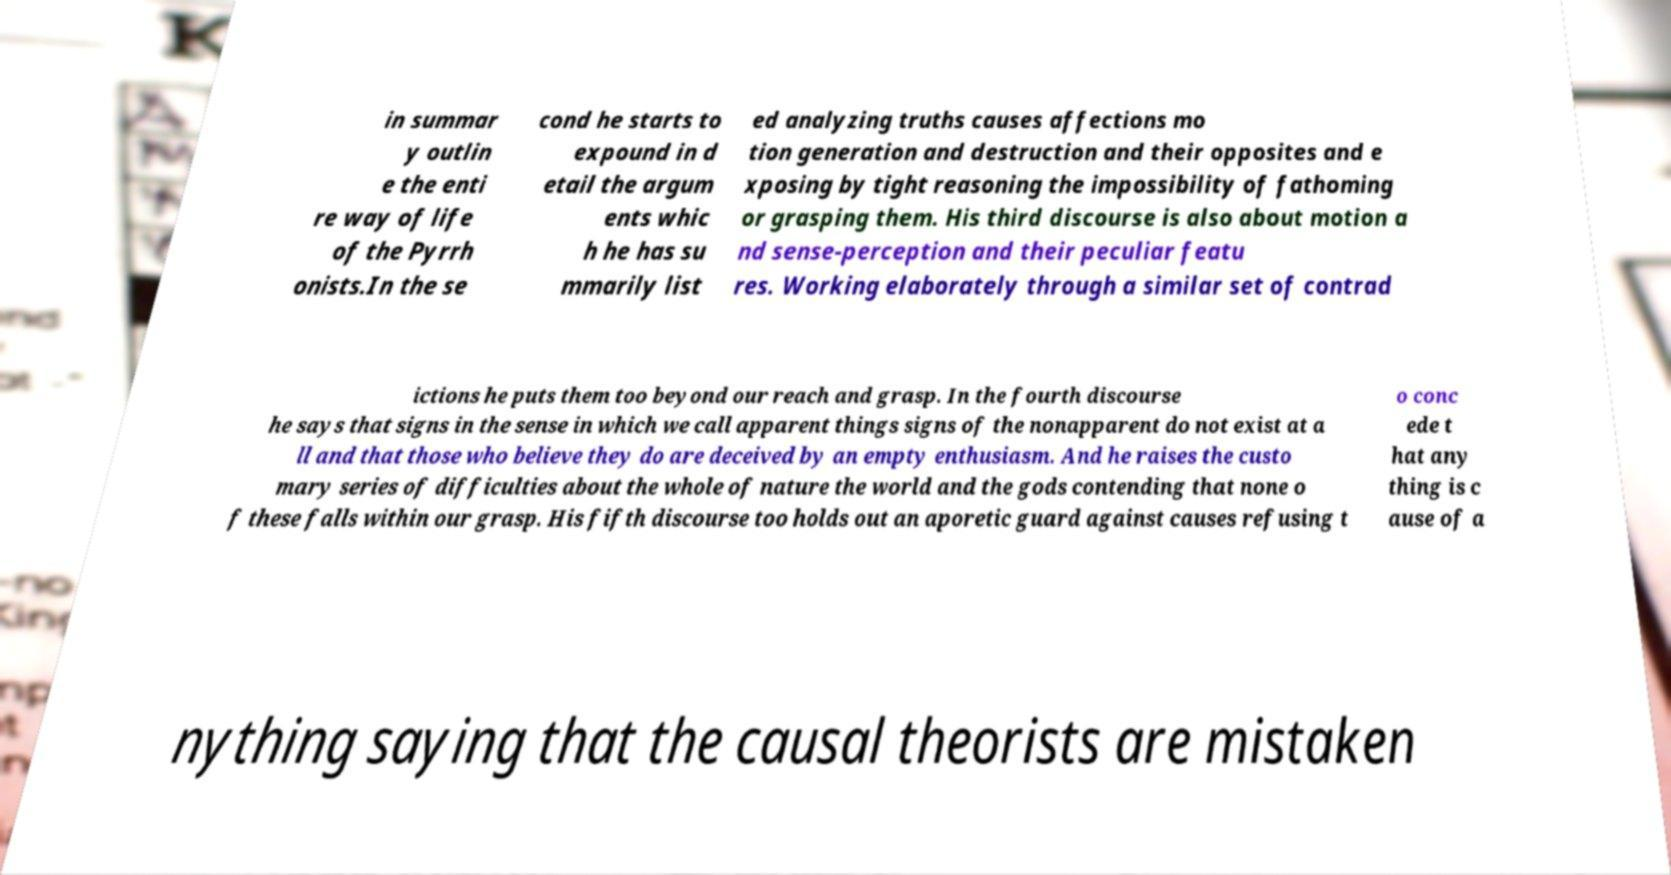Can you accurately transcribe the text from the provided image for me? in summar y outlin e the enti re way of life of the Pyrrh onists.In the se cond he starts to expound in d etail the argum ents whic h he has su mmarily list ed analyzing truths causes affections mo tion generation and destruction and their opposites and e xposing by tight reasoning the impossibility of fathoming or grasping them. His third discourse is also about motion a nd sense-perception and their peculiar featu res. Working elaborately through a similar set of contrad ictions he puts them too beyond our reach and grasp. In the fourth discourse he says that signs in the sense in which we call apparent things signs of the nonapparent do not exist at a ll and that those who believe they do are deceived by an empty enthusiasm. And he raises the custo mary series of difficulties about the whole of nature the world and the gods contending that none o f these falls within our grasp. His fifth discourse too holds out an aporetic guard against causes refusing t o conc ede t hat any thing is c ause of a nything saying that the causal theorists are mistaken 